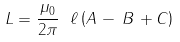Convert formula to latex. <formula><loc_0><loc_0><loc_500><loc_500>L = { \frac { \mu _ { 0 } } { 2 \pi } } \ \ell \left ( A \, - \, B \, + C \right )</formula> 